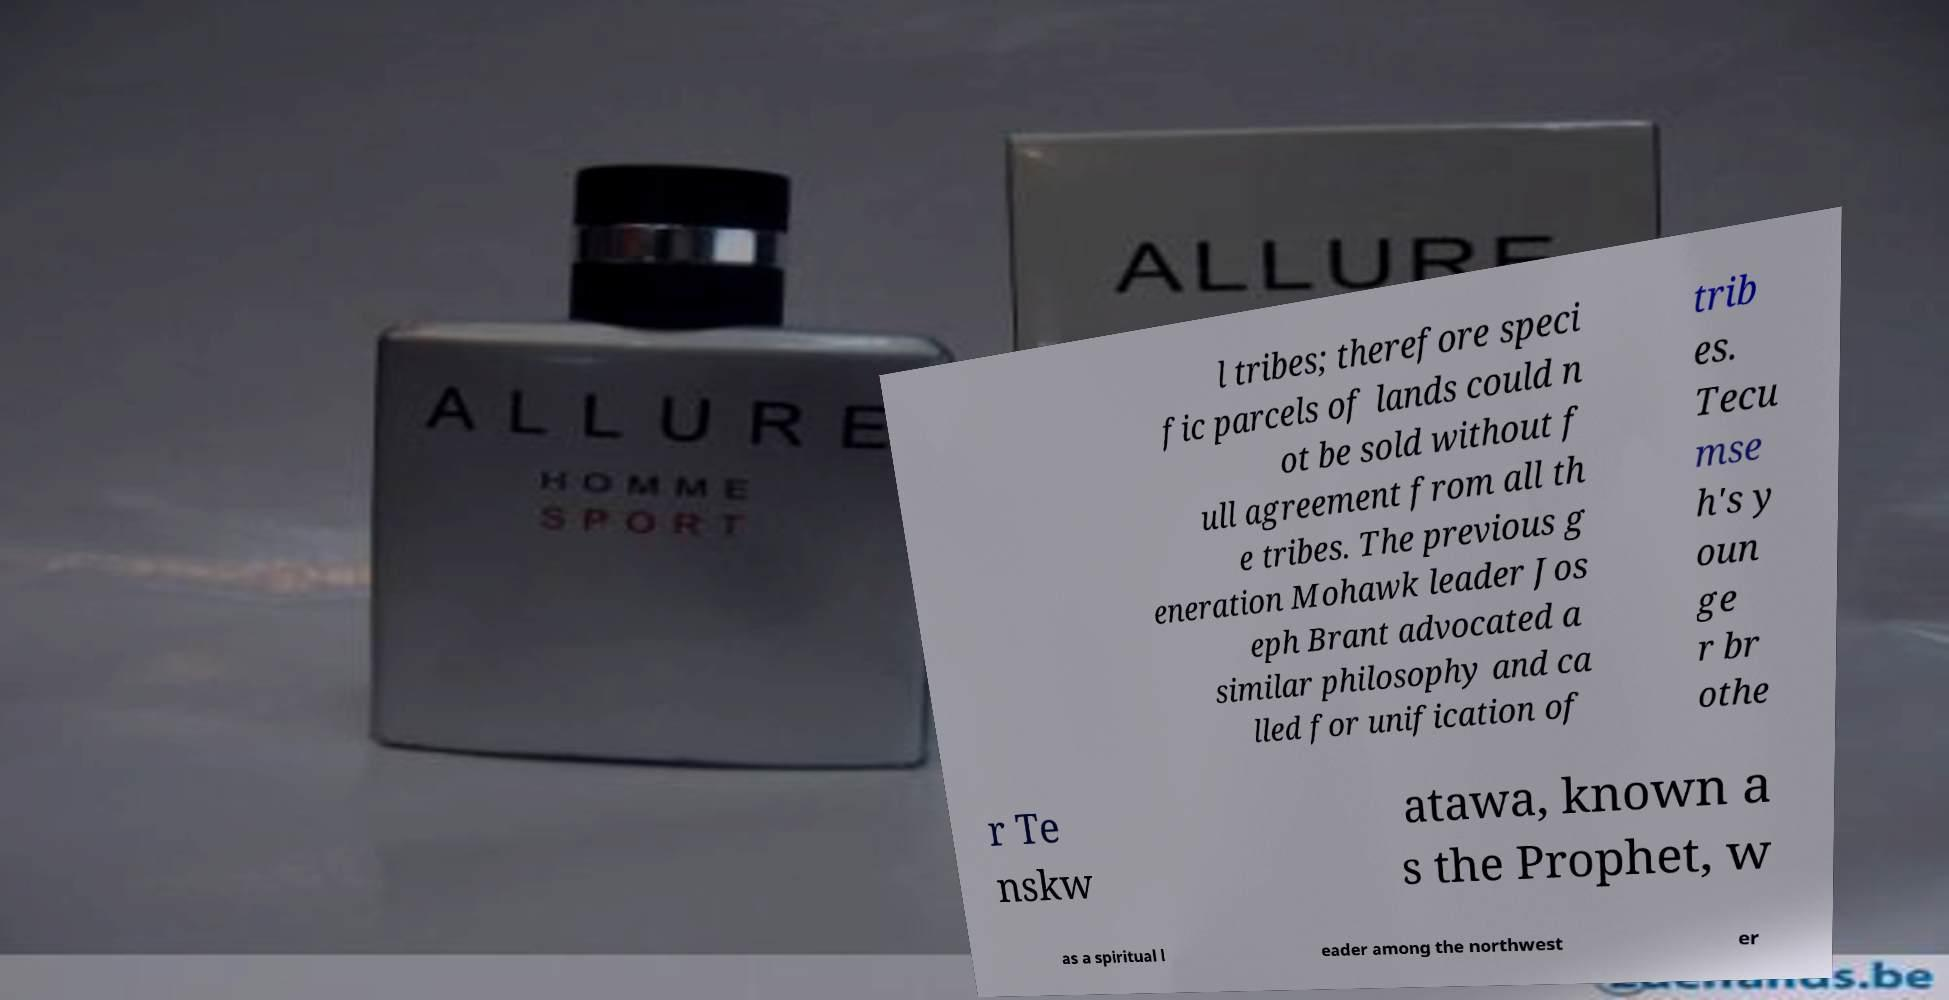I need the written content from this picture converted into text. Can you do that? l tribes; therefore speci fic parcels of lands could n ot be sold without f ull agreement from all th e tribes. The previous g eneration Mohawk leader Jos eph Brant advocated a similar philosophy and ca lled for unification of trib es. Tecu mse h's y oun ge r br othe r Te nskw atawa, known a s the Prophet, w as a spiritual l eader among the northwest er 